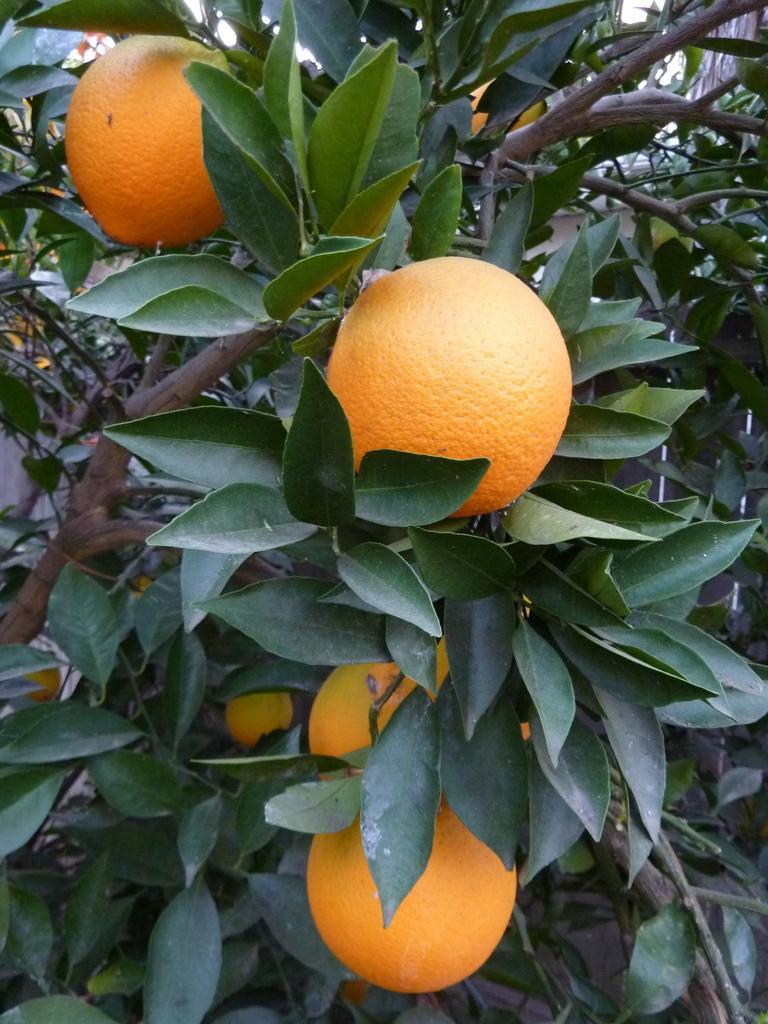In one or two sentences, can you explain what this image depicts? This is a zoomed in picture. In the foreground we can see the oranges hanging on the tree and we can see the green leaves, branches and stems of the tree. 